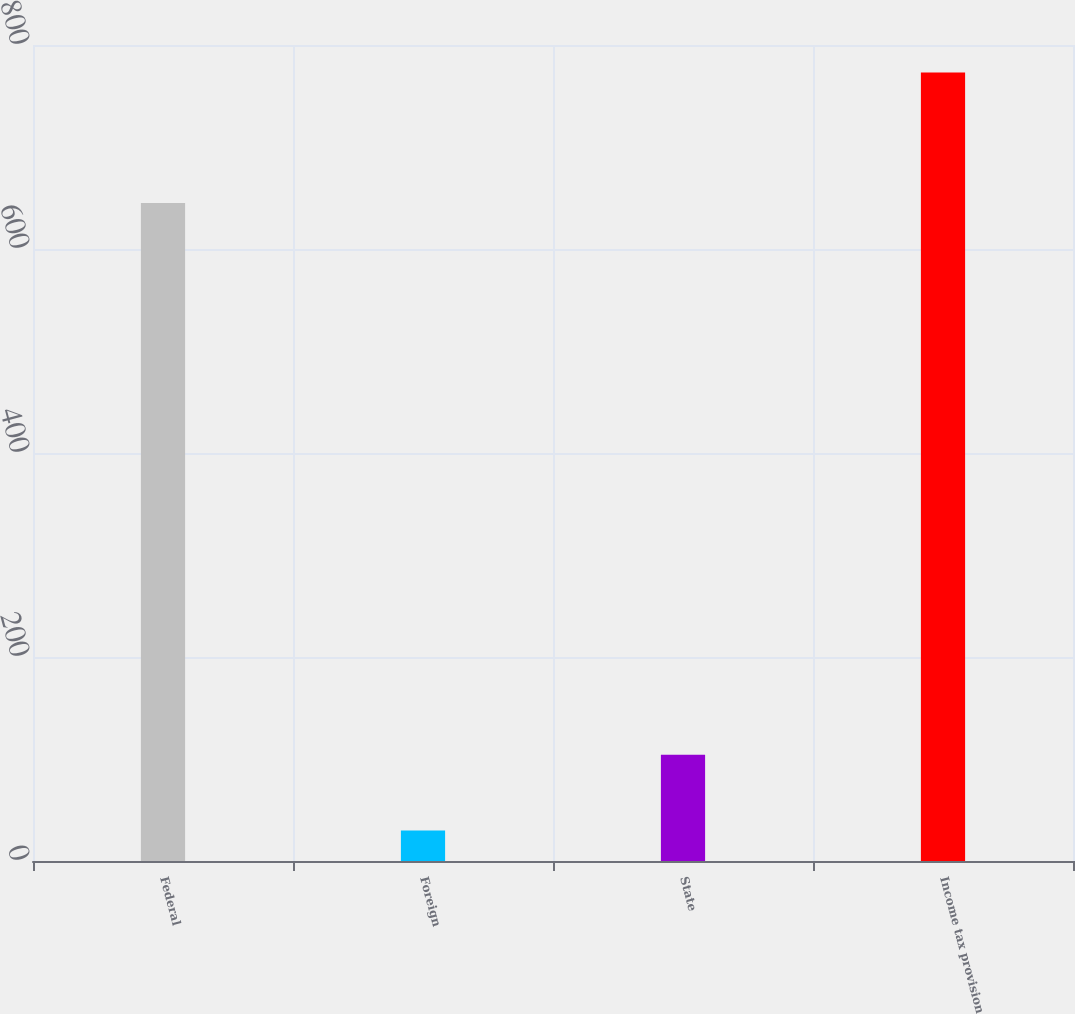Convert chart. <chart><loc_0><loc_0><loc_500><loc_500><bar_chart><fcel>Federal<fcel>Foreign<fcel>State<fcel>Income tax provision<nl><fcel>645.2<fcel>29.8<fcel>104.12<fcel>773<nl></chart> 